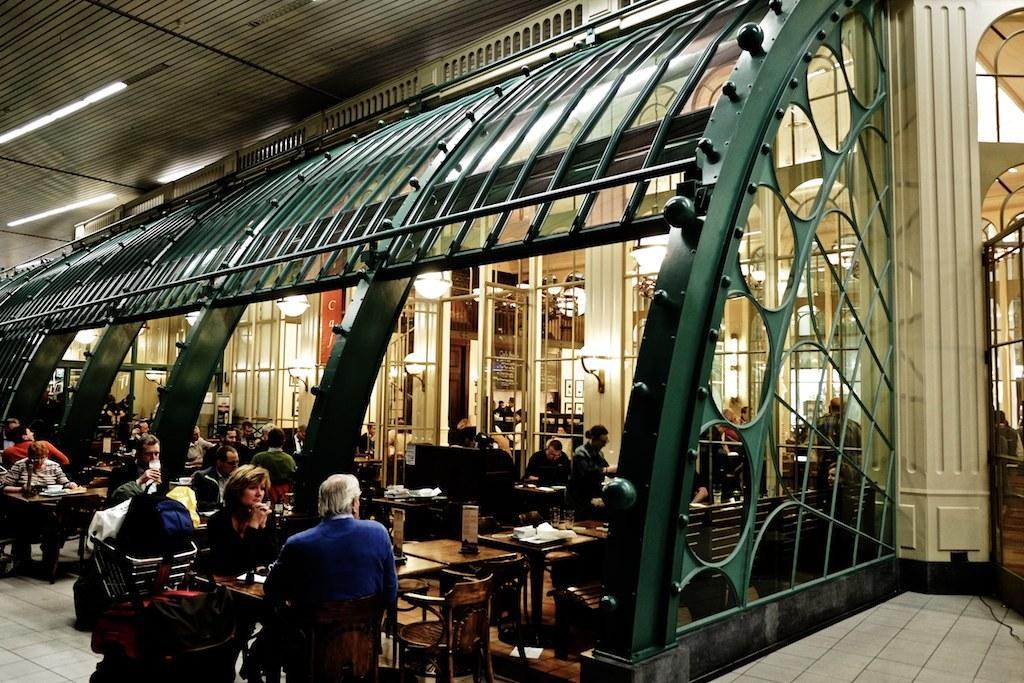Can you describe this image briefly? In this image we can see a group of people sitting on the chairs beside the tables under a roof. We can also see some lights to a roof. On the backside we can see some windows, doors and some chandeliers. 